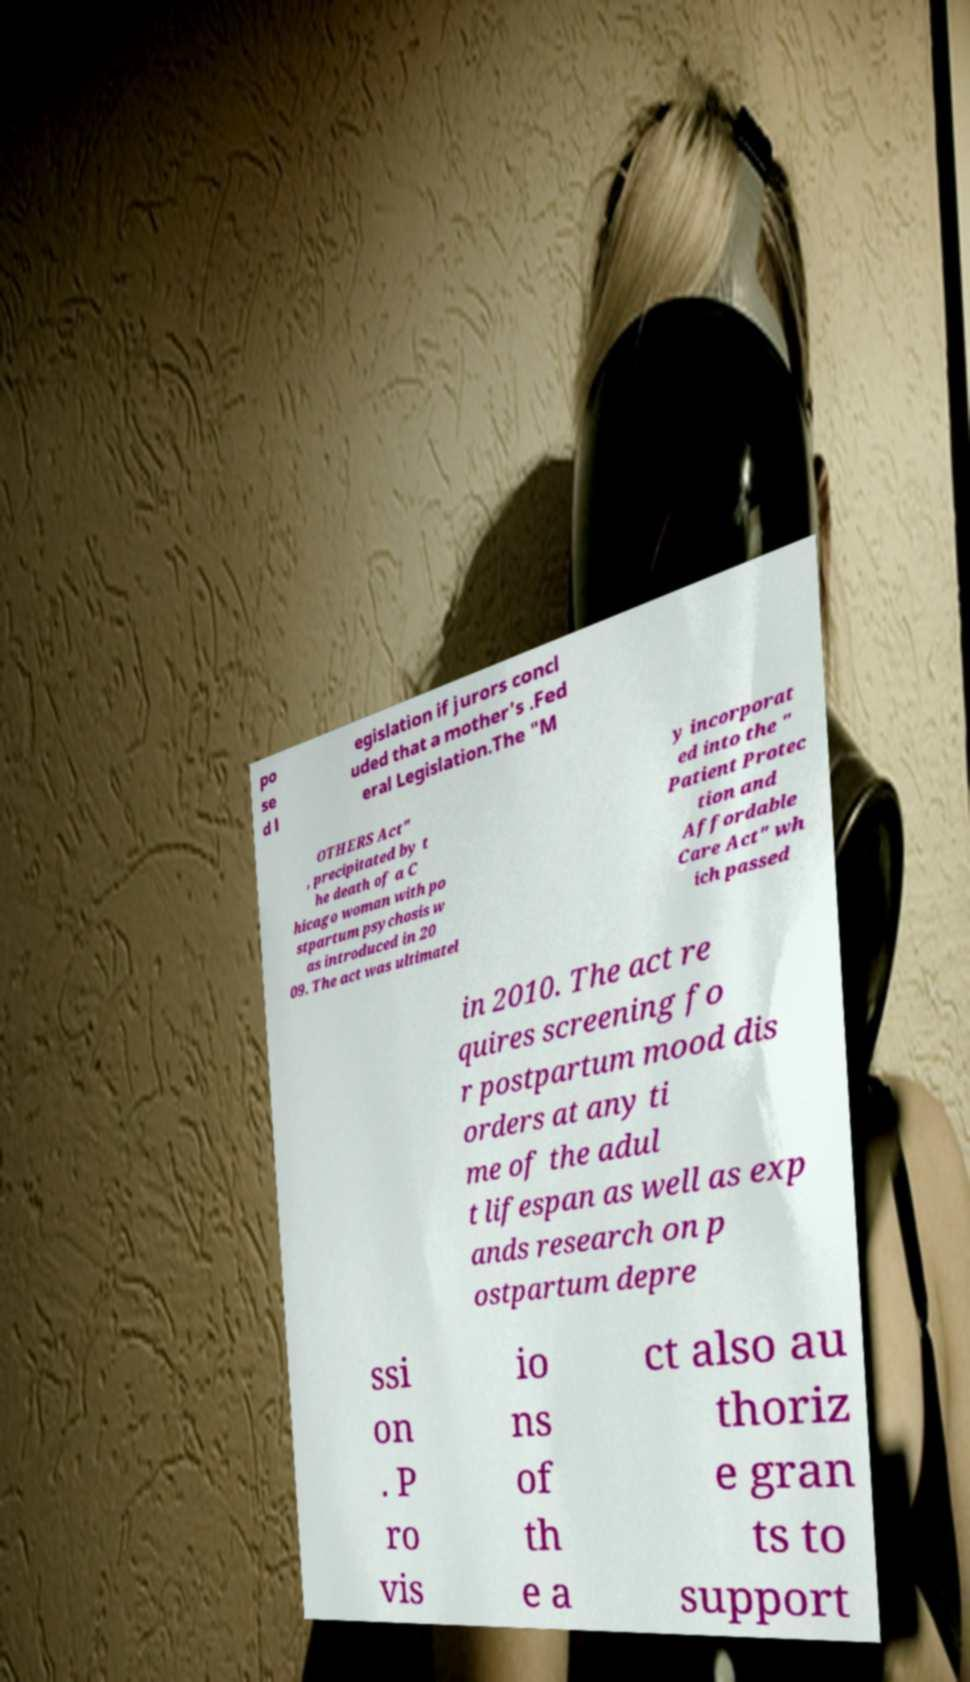Can you accurately transcribe the text from the provided image for me? po se d l egislation if jurors concl uded that a mother's .Fed eral Legislation.The "M OTHERS Act" , precipitated by t he death of a C hicago woman with po stpartum psychosis w as introduced in 20 09. The act was ultimatel y incorporat ed into the " Patient Protec tion and Affordable Care Act" wh ich passed in 2010. The act re quires screening fo r postpartum mood dis orders at any ti me of the adul t lifespan as well as exp ands research on p ostpartum depre ssi on . P ro vis io ns of th e a ct also au thoriz e gran ts to support 